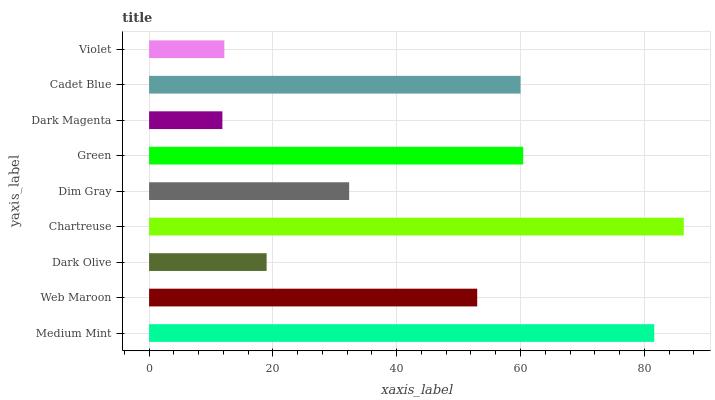Is Dark Magenta the minimum?
Answer yes or no. Yes. Is Chartreuse the maximum?
Answer yes or no. Yes. Is Web Maroon the minimum?
Answer yes or no. No. Is Web Maroon the maximum?
Answer yes or no. No. Is Medium Mint greater than Web Maroon?
Answer yes or no. Yes. Is Web Maroon less than Medium Mint?
Answer yes or no. Yes. Is Web Maroon greater than Medium Mint?
Answer yes or no. No. Is Medium Mint less than Web Maroon?
Answer yes or no. No. Is Web Maroon the high median?
Answer yes or no. Yes. Is Web Maroon the low median?
Answer yes or no. Yes. Is Dim Gray the high median?
Answer yes or no. No. Is Green the low median?
Answer yes or no. No. 